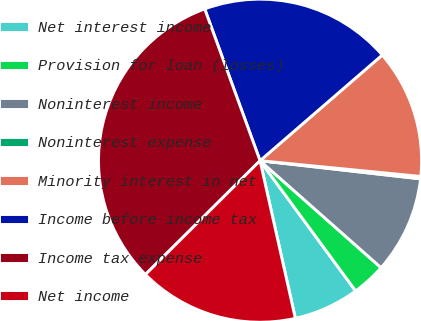<chart> <loc_0><loc_0><loc_500><loc_500><pie_chart><fcel>Net interest income<fcel>Provision for loan (losses)<fcel>Noninterest income<fcel>Noninterest expense<fcel>Minority interest in net<fcel>Income before income tax<fcel>Income tax expense<fcel>Net income<nl><fcel>6.57%<fcel>3.4%<fcel>9.73%<fcel>0.24%<fcel>12.9%<fcel>19.22%<fcel>31.88%<fcel>16.06%<nl></chart> 